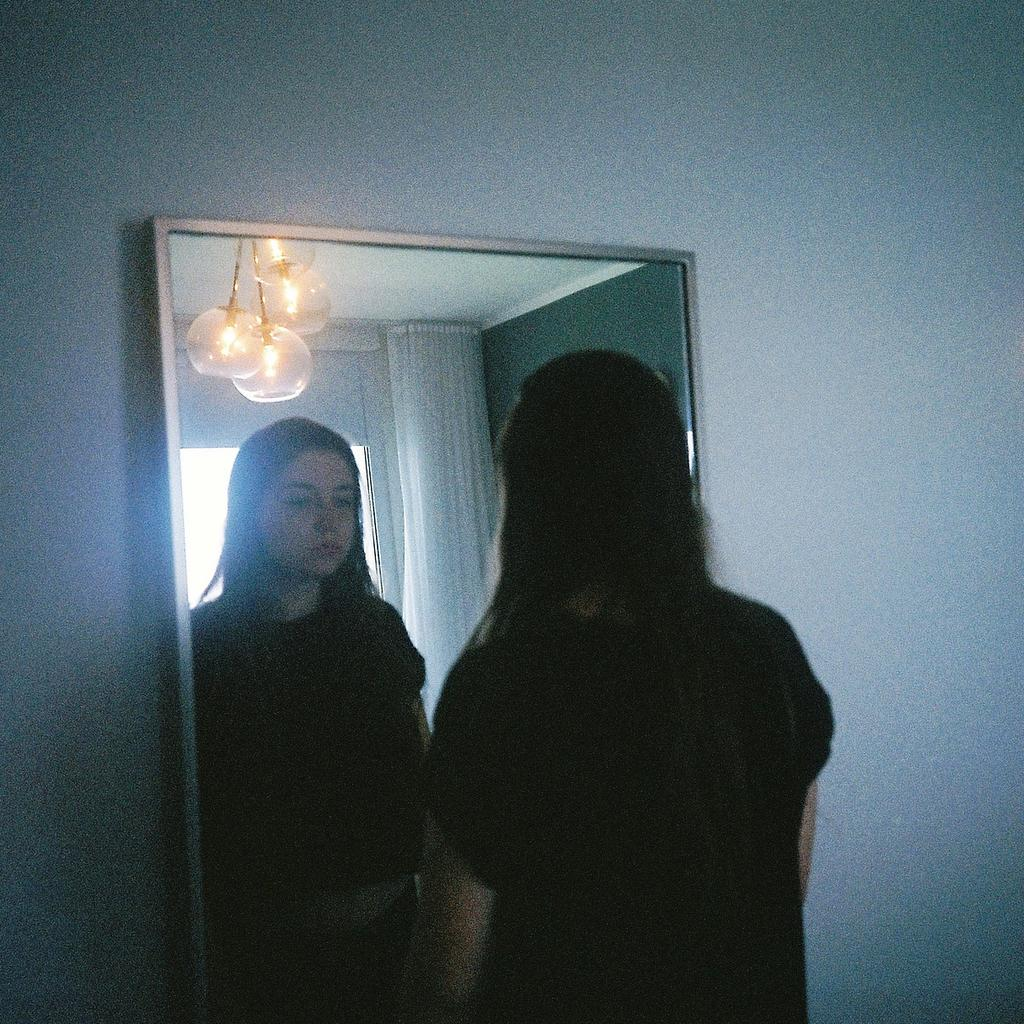Who is present in the image? There is a woman in the image. What is the woman doing in the image? The woman is standing on the floor and looking into a mirror. Where is the mirror located in relation to the woman? The mirror is in front of the woman. What can be seen at the top of the image? There are lights at the top of the image. How many muscles can be seen flexing in the image? There is no indication of muscles flexing in the image, as it primarily focuses on the woman looking into a mirror. 